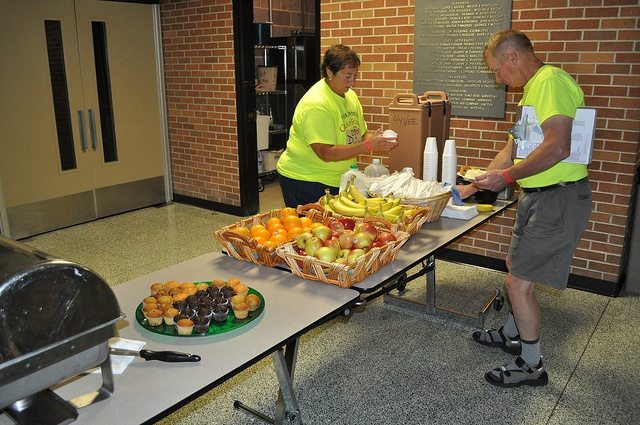Describe the objects in this image and their specific colors. I can see dining table in black, darkgray, gray, and tan tones, people in black, gray, and maroon tones, people in black, khaki, brown, and olive tones, cake in black, red, orange, and maroon tones, and banana in black, olive, khaki, and gold tones in this image. 